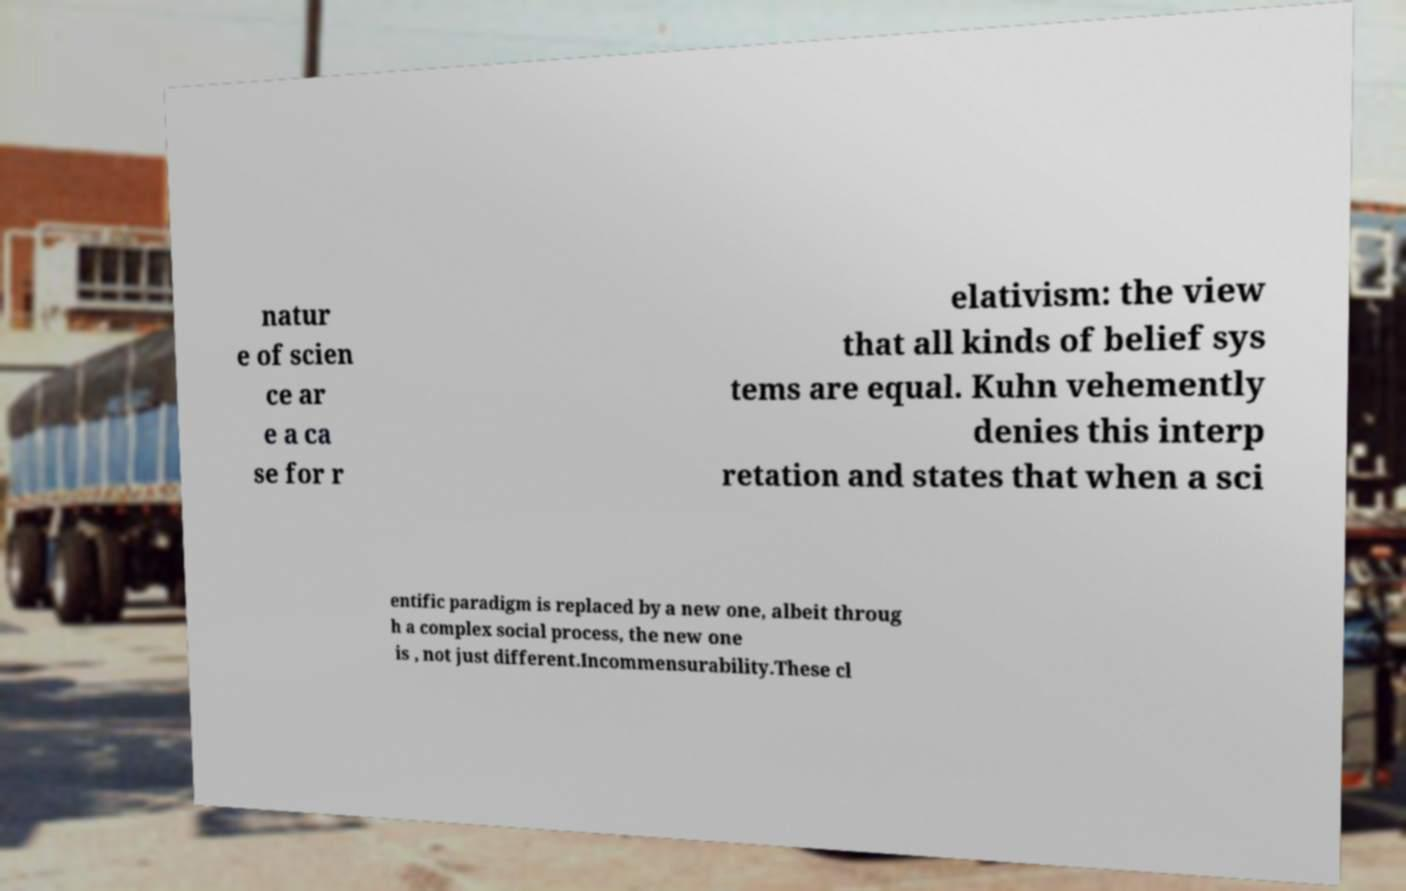What messages or text are displayed in this image? I need them in a readable, typed format. natur e of scien ce ar e a ca se for r elativism: the view that all kinds of belief sys tems are equal. Kuhn vehemently denies this interp retation and states that when a sci entific paradigm is replaced by a new one, albeit throug h a complex social process, the new one is , not just different.Incommensurability.These cl 